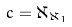Convert formula to latex. <formula><loc_0><loc_0><loc_500><loc_500>c = \aleph _ { \aleph _ { 1 } }</formula> 